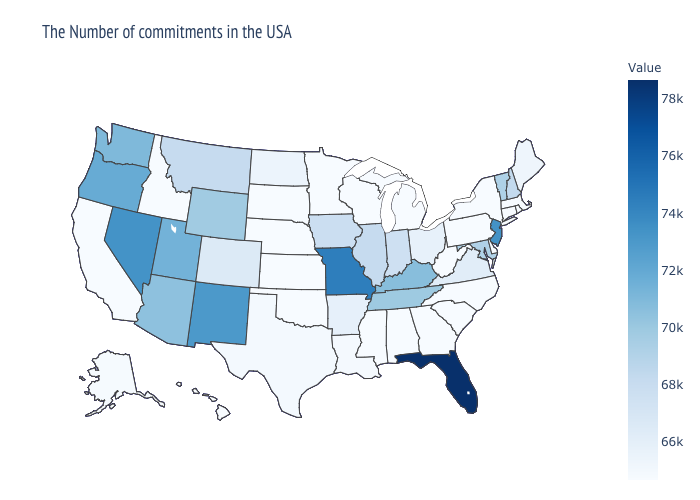Among the states that border Tennessee , does Missouri have the highest value?
Write a very short answer. Yes. Which states hav the highest value in the MidWest?
Concise answer only. Missouri. Is the legend a continuous bar?
Give a very brief answer. Yes. Among the states that border Connecticut , which have the highest value?
Concise answer only. Massachusetts, Rhode Island, New York. Does Nevada have the highest value in the USA?
Give a very brief answer. No. Does New Jersey have the highest value in the USA?
Short answer required. No. Which states have the highest value in the USA?
Keep it brief. Florida. 